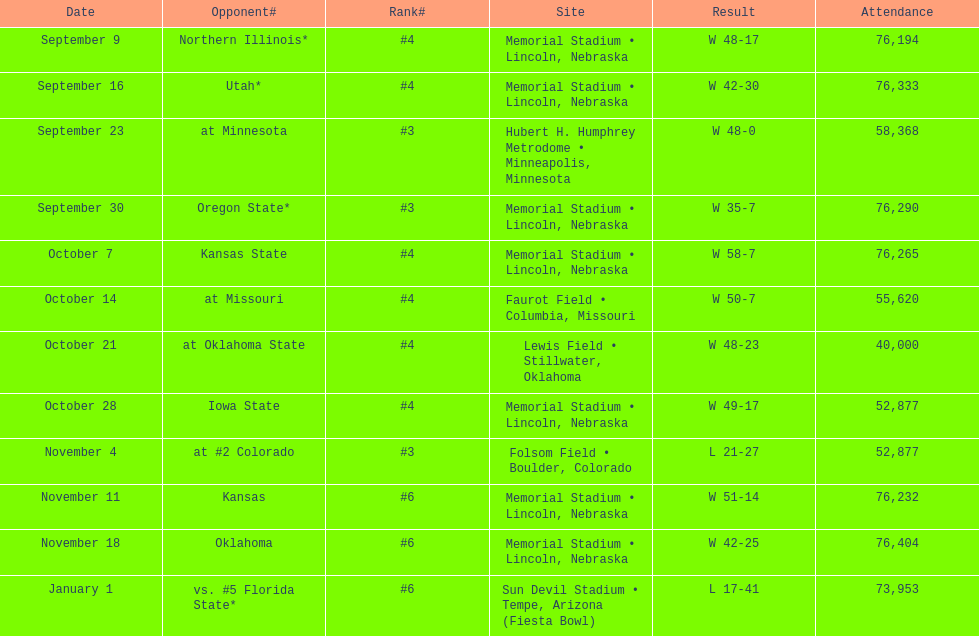What is the site listed following lewis field? Memorial Stadium • Lincoln, Nebraska. 